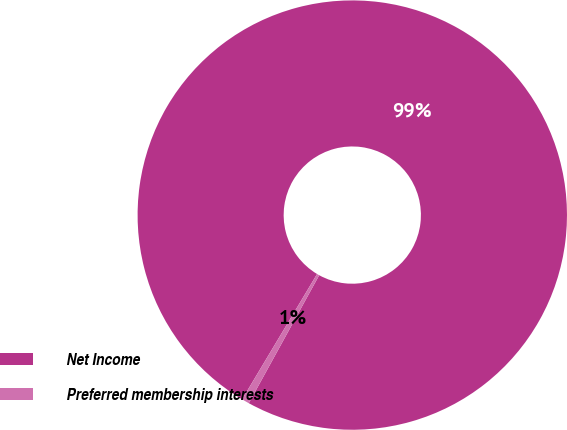Convert chart. <chart><loc_0><loc_0><loc_500><loc_500><pie_chart><fcel>Net Income<fcel>Preferred membership interests<nl><fcel>99.43%<fcel>0.57%<nl></chart> 